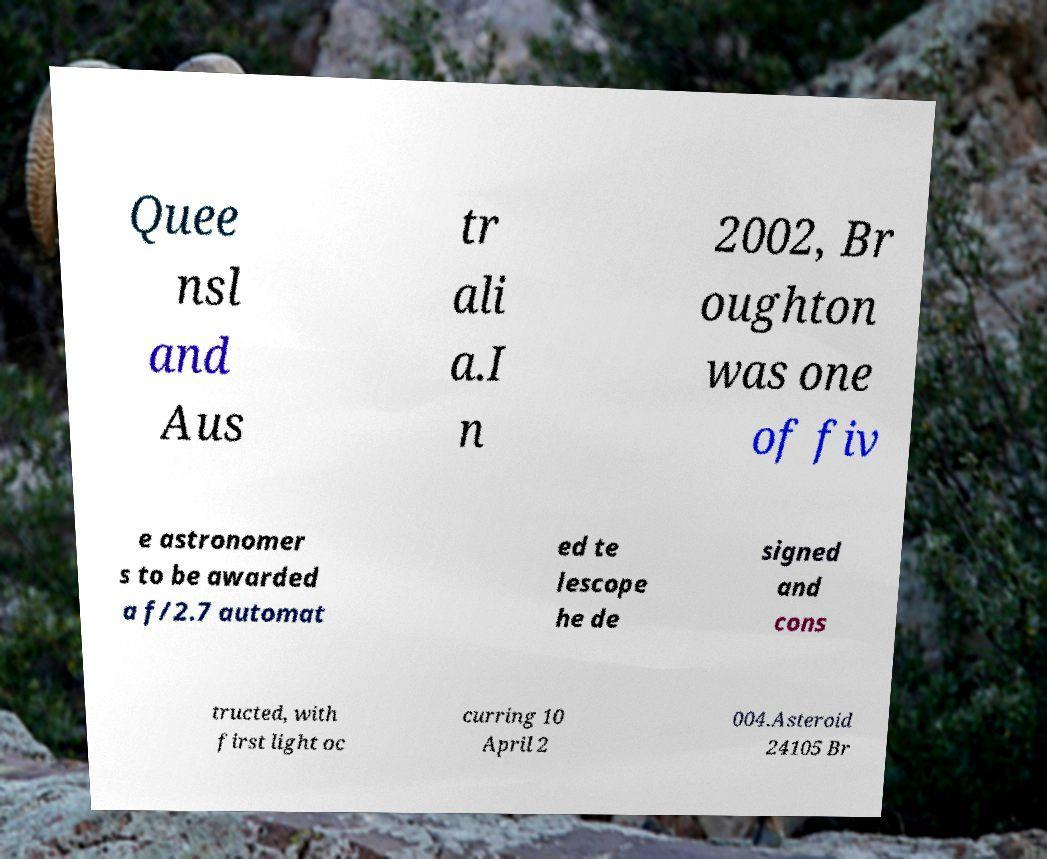I need the written content from this picture converted into text. Can you do that? Quee nsl and Aus tr ali a.I n 2002, Br oughton was one of fiv e astronomer s to be awarded a f/2.7 automat ed te lescope he de signed and cons tructed, with first light oc curring 10 April 2 004.Asteroid 24105 Br 